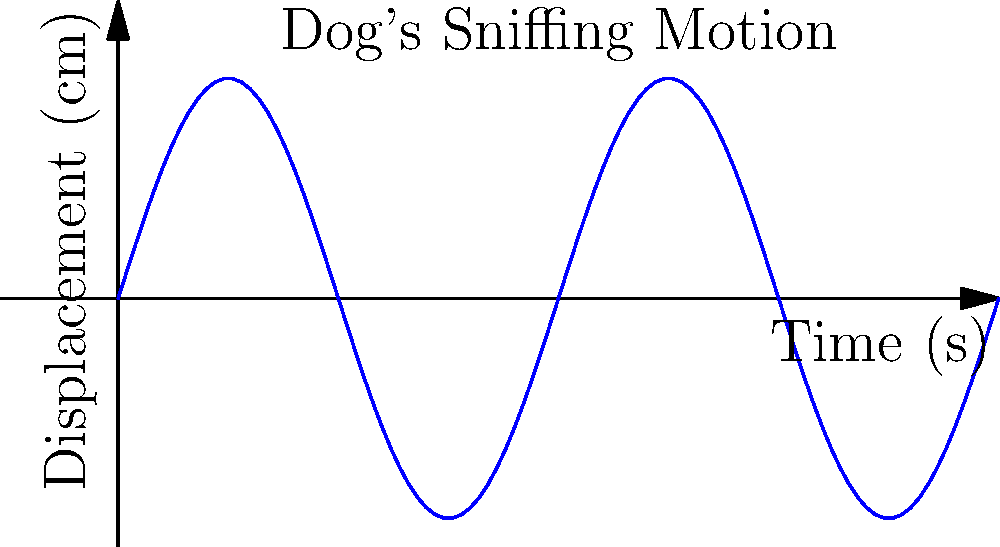The graph above represents the displacement of a dog's nose during a sniffing motion. If the dog performs 2 complete sniffs per second, what is the maximum velocity (in cm/s) of the dog's nose during this motion? To find the maximum velocity of the dog's nose, we need to follow these steps:

1. Identify the equation of motion:
   The displacement $y$ is given by $y = 0.5 \sin(2\pi x)$, where $x$ is time in seconds.

2. Calculate the velocity function:
   Velocity is the derivative of displacement with respect to time.
   $v = \frac{dy}{dx} = 0.5 \cdot 2\pi \cos(2\pi x) = \pi \cos(2\pi x)$

3. Find the maximum velocity:
   The maximum value of cosine is 1, so the maximum velocity occurs when $\cos(2\pi x) = 1$.

4. Calculate the maximum velocity:
   $v_{max} = \pi$ cm/s

5. Convert to the correct units:
   The question asks for cm/s, so no conversion is needed.

Therefore, the maximum velocity of the dog's nose during the sniffing motion is $\pi$ cm/s or approximately 3.14 cm/s.
Answer: $\pi$ cm/s 